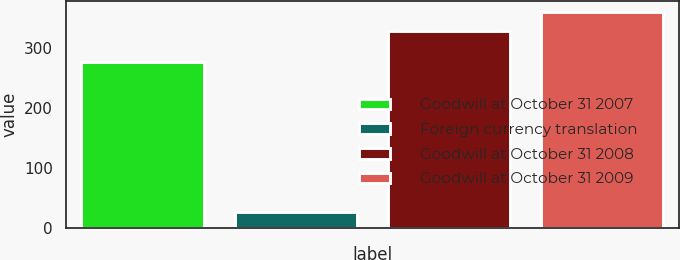Convert chart to OTSL. <chart><loc_0><loc_0><loc_500><loc_500><bar_chart><fcel>Goodwill at October 31 2007<fcel>Foreign currency translation<fcel>Goodwill at October 31 2008<fcel>Goodwill at October 31 2009<nl><fcel>277<fcel>27<fcel>329<fcel>359.9<nl></chart> 